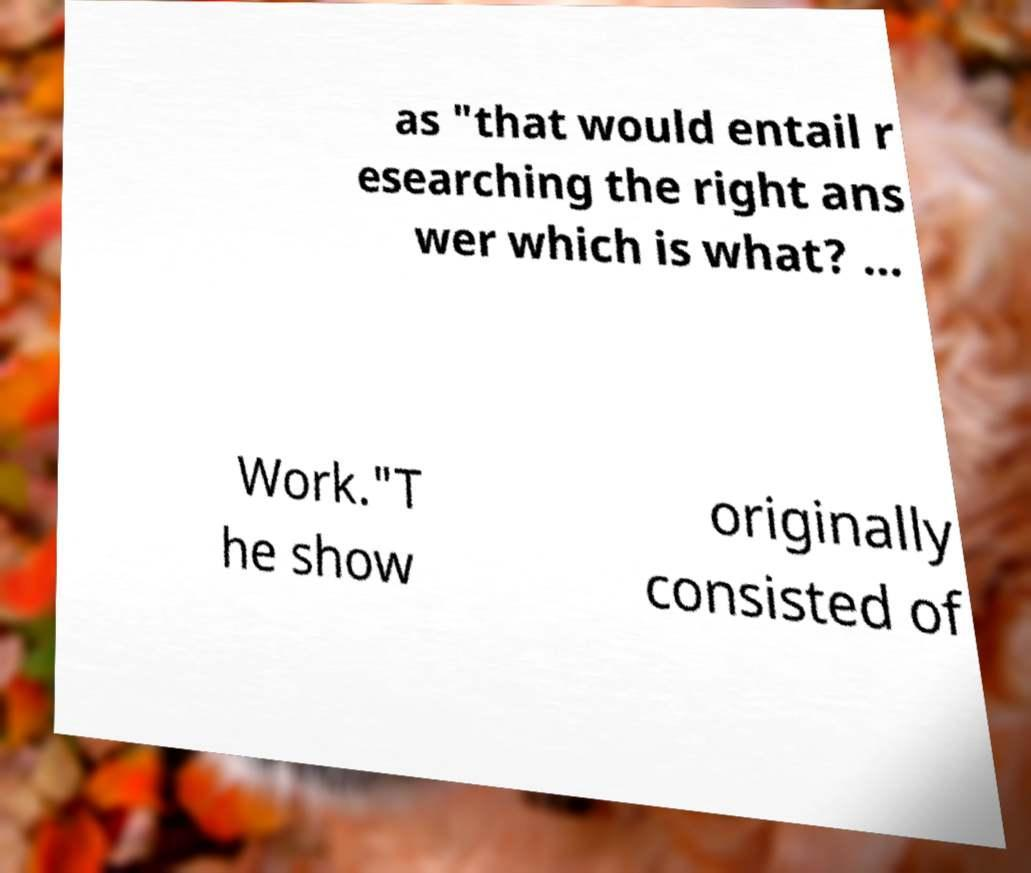What messages or text are displayed in this image? I need them in a readable, typed format. as "that would entail r esearching the right ans wer which is what? ... Work."T he show originally consisted of 